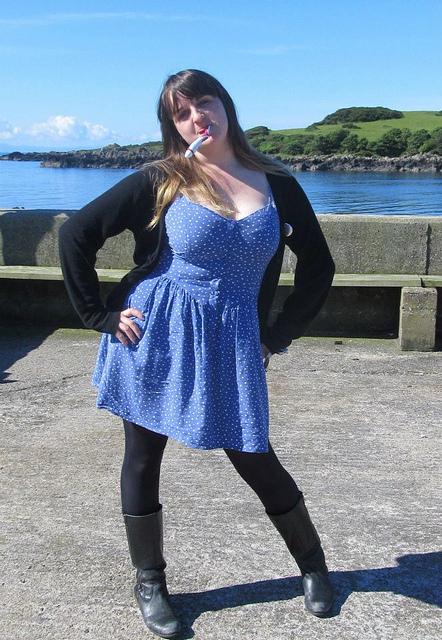Is the lady wearing sneakers?
Give a very brief answer. No. What is in her mouth?
Write a very short answer. Toothbrush. Is she posing?
Short answer required. Yes. 